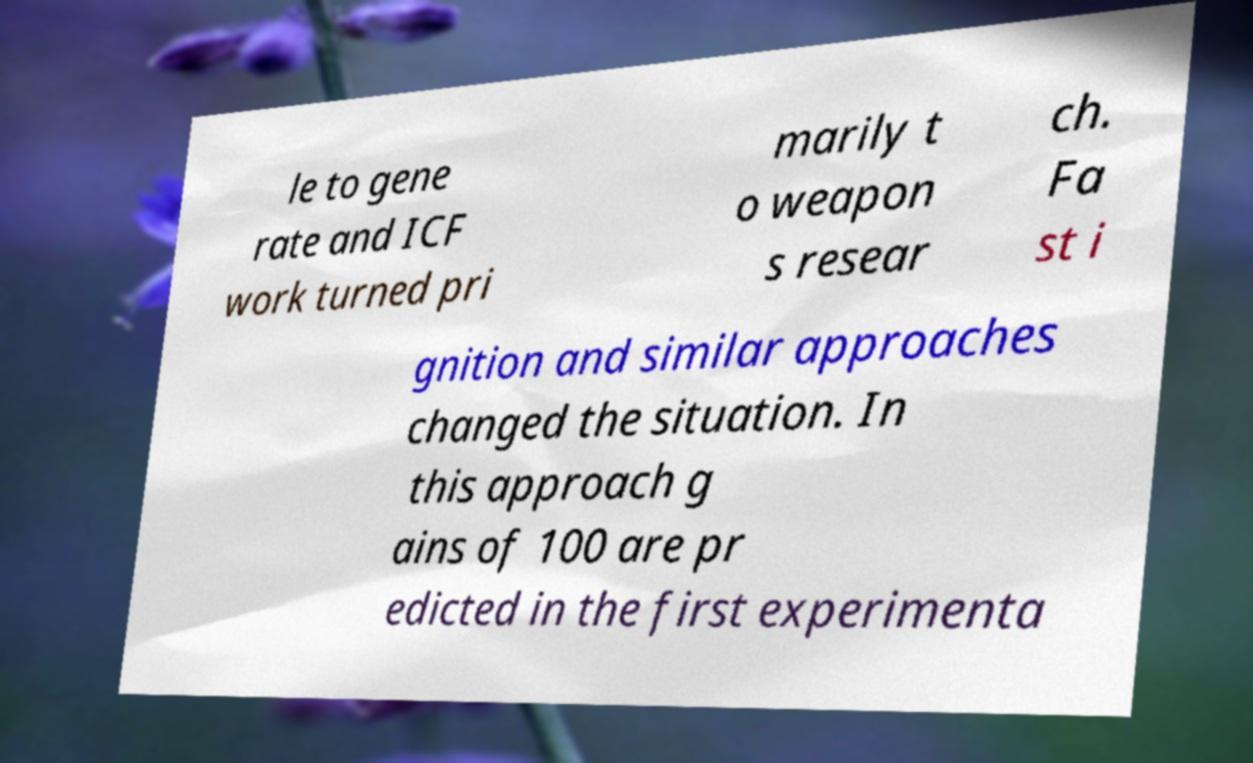Please identify and transcribe the text found in this image. le to gene rate and ICF work turned pri marily t o weapon s resear ch. Fa st i gnition and similar approaches changed the situation. In this approach g ains of 100 are pr edicted in the first experimenta 